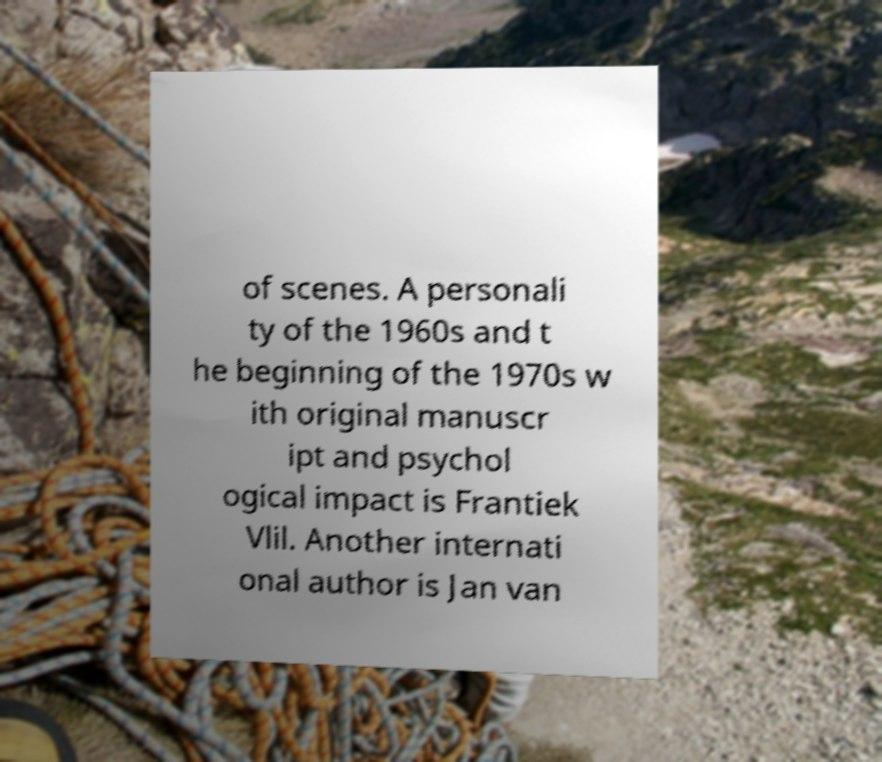Could you assist in decoding the text presented in this image and type it out clearly? of scenes. A personali ty of the 1960s and t he beginning of the 1970s w ith original manuscr ipt and psychol ogical impact is Frantiek Vlil. Another internati onal author is Jan van 